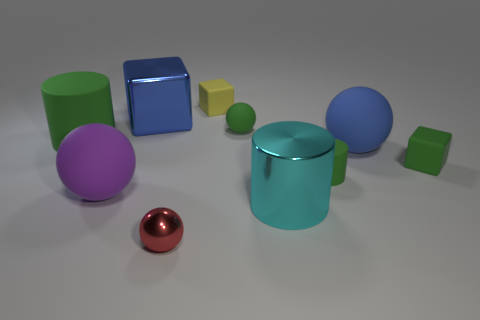Subtract all big blue balls. How many balls are left? 3 Subtract all green cylinders. How many cylinders are left? 1 Subtract 2 cylinders. How many cylinders are left? 1 Subtract all purple spheres. Subtract all green cylinders. How many spheres are left? 3 Subtract all yellow balls. How many yellow cylinders are left? 0 Subtract all tiny purple objects. Subtract all large metallic things. How many objects are left? 8 Add 3 large blue balls. How many large blue balls are left? 4 Add 4 yellow shiny blocks. How many yellow shiny blocks exist? 4 Subtract 1 blue cubes. How many objects are left? 9 Subtract all blocks. How many objects are left? 7 